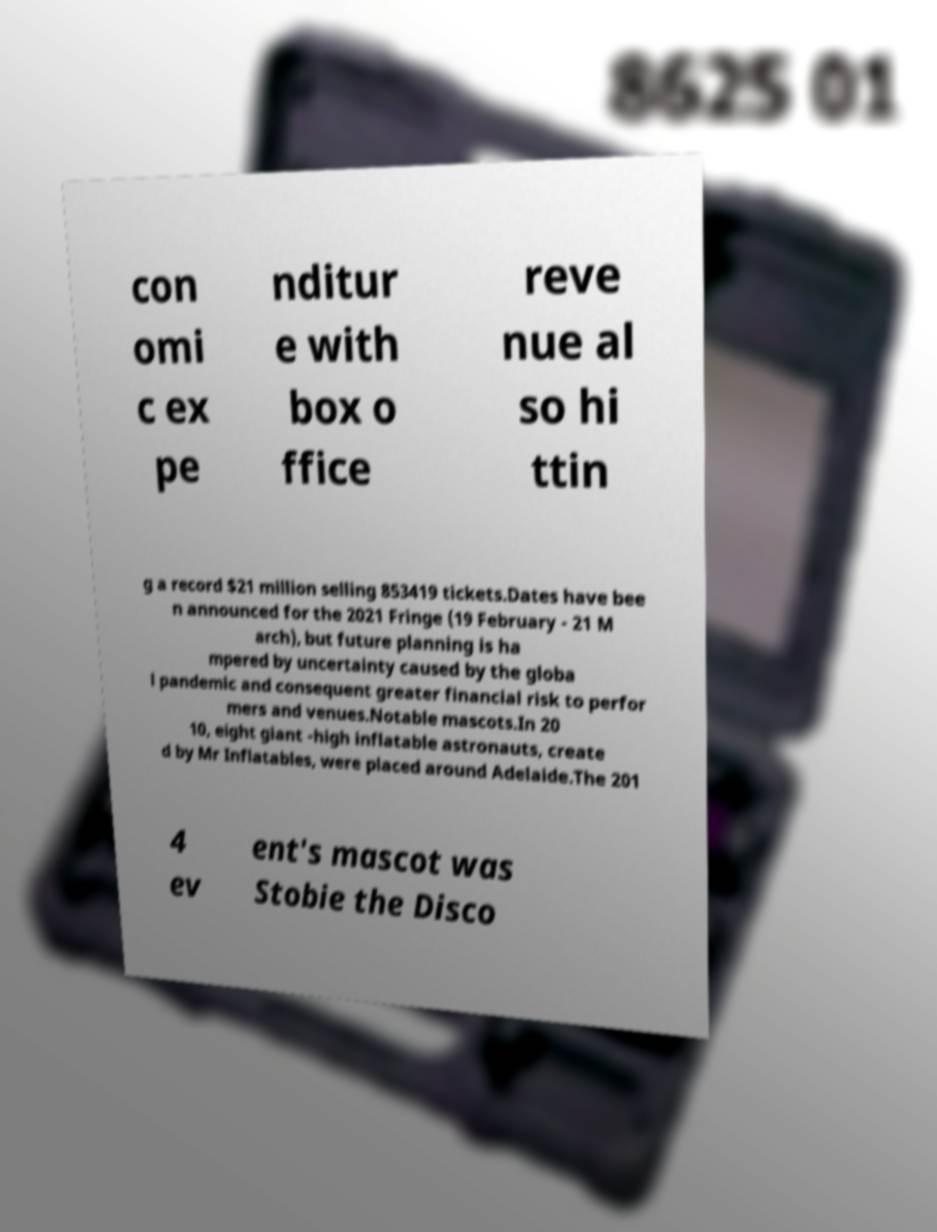Can you accurately transcribe the text from the provided image for me? con omi c ex pe nditur e with box o ffice reve nue al so hi ttin g a record $21 million selling 853419 tickets.Dates have bee n announced for the 2021 Fringe (19 February - 21 M arch), but future planning is ha mpered by uncertainty caused by the globa l pandemic and consequent greater financial risk to perfor mers and venues.Notable mascots.In 20 10, eight giant -high inflatable astronauts, create d by Mr Inflatables, were placed around Adelaide.The 201 4 ev ent's mascot was Stobie the Disco 